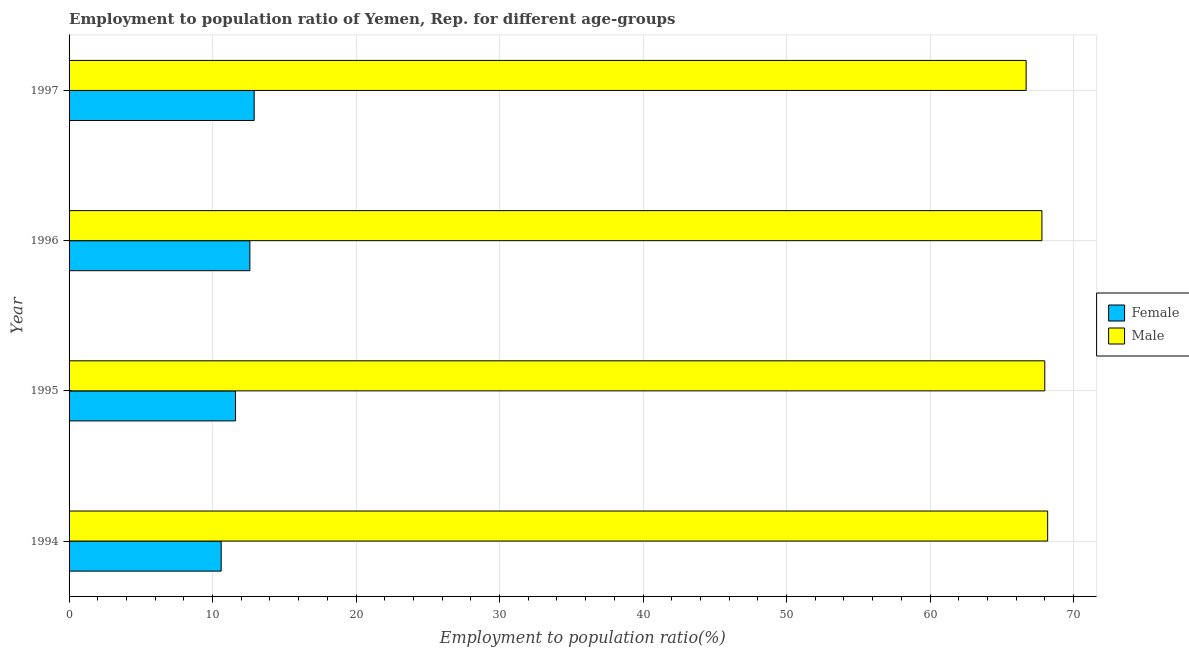How many different coloured bars are there?
Provide a succinct answer. 2. How many groups of bars are there?
Make the answer very short. 4. Are the number of bars per tick equal to the number of legend labels?
Offer a terse response. Yes. How many bars are there on the 2nd tick from the top?
Ensure brevity in your answer.  2. How many bars are there on the 2nd tick from the bottom?
Keep it short and to the point. 2. What is the label of the 4th group of bars from the top?
Make the answer very short. 1994. What is the employment to population ratio(female) in 1997?
Your response must be concise. 12.9. Across all years, what is the maximum employment to population ratio(male)?
Keep it short and to the point. 68.2. Across all years, what is the minimum employment to population ratio(female)?
Your response must be concise. 10.6. In which year was the employment to population ratio(female) maximum?
Make the answer very short. 1997. What is the total employment to population ratio(male) in the graph?
Your answer should be very brief. 270.7. What is the difference between the employment to population ratio(male) in 1994 and that in 1995?
Your response must be concise. 0.2. What is the difference between the employment to population ratio(female) in 1996 and the employment to population ratio(male) in 1994?
Make the answer very short. -55.6. What is the average employment to population ratio(male) per year?
Provide a succinct answer. 67.67. In the year 1994, what is the difference between the employment to population ratio(male) and employment to population ratio(female)?
Make the answer very short. 57.6. In how many years, is the employment to population ratio(female) greater than 2 %?
Provide a short and direct response. 4. What is the ratio of the employment to population ratio(male) in 1995 to that in 1997?
Offer a terse response. 1.02. Is the difference between the employment to population ratio(male) in 1994 and 1995 greater than the difference between the employment to population ratio(female) in 1994 and 1995?
Your answer should be compact. Yes. In how many years, is the employment to population ratio(male) greater than the average employment to population ratio(male) taken over all years?
Give a very brief answer. 3. What does the 1st bar from the top in 1997 represents?
Provide a short and direct response. Male. Does the graph contain any zero values?
Keep it short and to the point. No. Does the graph contain grids?
Offer a very short reply. Yes. What is the title of the graph?
Your response must be concise. Employment to population ratio of Yemen, Rep. for different age-groups. Does "Register a property" appear as one of the legend labels in the graph?
Ensure brevity in your answer.  No. What is the Employment to population ratio(%) in Female in 1994?
Offer a very short reply. 10.6. What is the Employment to population ratio(%) of Male in 1994?
Ensure brevity in your answer.  68.2. What is the Employment to population ratio(%) of Female in 1995?
Your answer should be compact. 11.6. What is the Employment to population ratio(%) in Male in 1995?
Offer a very short reply. 68. What is the Employment to population ratio(%) in Female in 1996?
Your response must be concise. 12.6. What is the Employment to population ratio(%) in Male in 1996?
Your answer should be compact. 67.8. What is the Employment to population ratio(%) in Female in 1997?
Provide a succinct answer. 12.9. What is the Employment to population ratio(%) in Male in 1997?
Make the answer very short. 66.7. Across all years, what is the maximum Employment to population ratio(%) of Female?
Offer a very short reply. 12.9. Across all years, what is the maximum Employment to population ratio(%) of Male?
Your answer should be very brief. 68.2. Across all years, what is the minimum Employment to population ratio(%) in Female?
Offer a terse response. 10.6. Across all years, what is the minimum Employment to population ratio(%) of Male?
Give a very brief answer. 66.7. What is the total Employment to population ratio(%) in Female in the graph?
Offer a terse response. 47.7. What is the total Employment to population ratio(%) in Male in the graph?
Offer a terse response. 270.7. What is the difference between the Employment to population ratio(%) of Female in 1994 and that in 1996?
Provide a short and direct response. -2. What is the difference between the Employment to population ratio(%) of Male in 1994 and that in 1996?
Offer a terse response. 0.4. What is the difference between the Employment to population ratio(%) in Female in 1994 and that in 1997?
Make the answer very short. -2.3. What is the difference between the Employment to population ratio(%) of Male in 1994 and that in 1997?
Give a very brief answer. 1.5. What is the difference between the Employment to population ratio(%) in Female in 1994 and the Employment to population ratio(%) in Male in 1995?
Provide a short and direct response. -57.4. What is the difference between the Employment to population ratio(%) of Female in 1994 and the Employment to population ratio(%) of Male in 1996?
Make the answer very short. -57.2. What is the difference between the Employment to population ratio(%) in Female in 1994 and the Employment to population ratio(%) in Male in 1997?
Provide a short and direct response. -56.1. What is the difference between the Employment to population ratio(%) in Female in 1995 and the Employment to population ratio(%) in Male in 1996?
Ensure brevity in your answer.  -56.2. What is the difference between the Employment to population ratio(%) in Female in 1995 and the Employment to population ratio(%) in Male in 1997?
Make the answer very short. -55.1. What is the difference between the Employment to population ratio(%) of Female in 1996 and the Employment to population ratio(%) of Male in 1997?
Provide a succinct answer. -54.1. What is the average Employment to population ratio(%) of Female per year?
Keep it short and to the point. 11.93. What is the average Employment to population ratio(%) in Male per year?
Provide a succinct answer. 67.67. In the year 1994, what is the difference between the Employment to population ratio(%) of Female and Employment to population ratio(%) of Male?
Your answer should be compact. -57.6. In the year 1995, what is the difference between the Employment to population ratio(%) of Female and Employment to population ratio(%) of Male?
Ensure brevity in your answer.  -56.4. In the year 1996, what is the difference between the Employment to population ratio(%) in Female and Employment to population ratio(%) in Male?
Provide a succinct answer. -55.2. In the year 1997, what is the difference between the Employment to population ratio(%) in Female and Employment to population ratio(%) in Male?
Offer a terse response. -53.8. What is the ratio of the Employment to population ratio(%) in Female in 1994 to that in 1995?
Keep it short and to the point. 0.91. What is the ratio of the Employment to population ratio(%) of Male in 1994 to that in 1995?
Keep it short and to the point. 1. What is the ratio of the Employment to population ratio(%) of Female in 1994 to that in 1996?
Your response must be concise. 0.84. What is the ratio of the Employment to population ratio(%) in Male in 1994 to that in 1996?
Your answer should be very brief. 1.01. What is the ratio of the Employment to population ratio(%) of Female in 1994 to that in 1997?
Make the answer very short. 0.82. What is the ratio of the Employment to population ratio(%) of Male in 1994 to that in 1997?
Your answer should be very brief. 1.02. What is the ratio of the Employment to population ratio(%) in Female in 1995 to that in 1996?
Keep it short and to the point. 0.92. What is the ratio of the Employment to population ratio(%) of Female in 1995 to that in 1997?
Offer a very short reply. 0.9. What is the ratio of the Employment to population ratio(%) of Male in 1995 to that in 1997?
Make the answer very short. 1.02. What is the ratio of the Employment to population ratio(%) in Female in 1996 to that in 1997?
Provide a short and direct response. 0.98. What is the ratio of the Employment to population ratio(%) in Male in 1996 to that in 1997?
Provide a succinct answer. 1.02. What is the difference between the highest and the second highest Employment to population ratio(%) in Male?
Your answer should be compact. 0.2. 